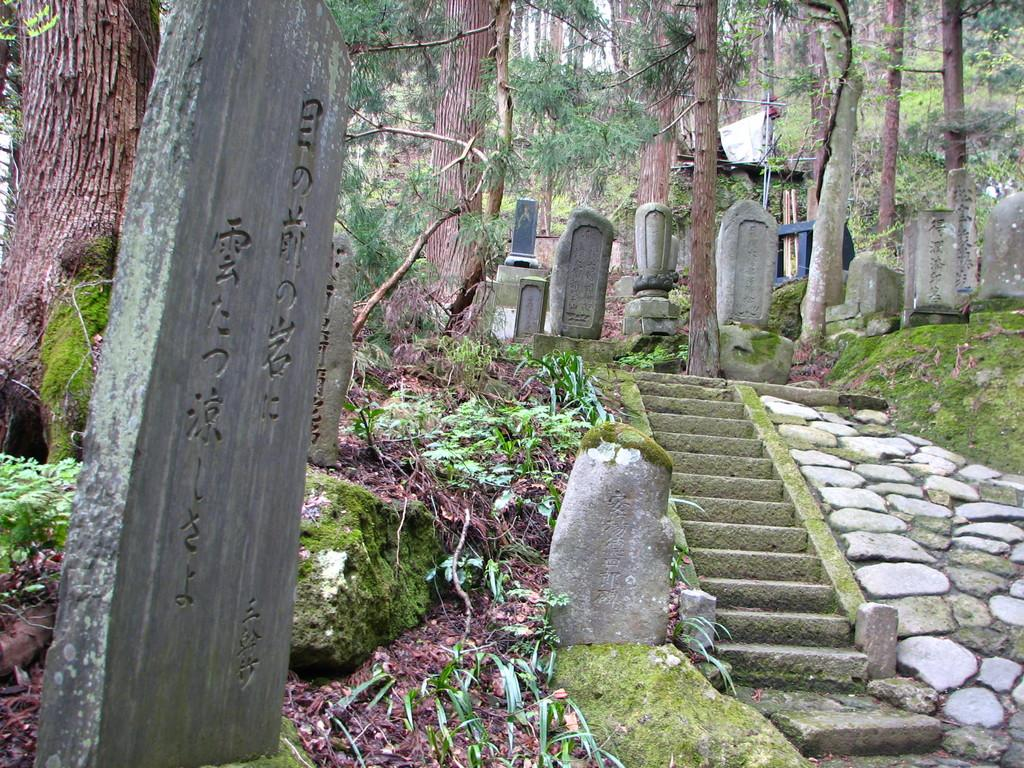What type of structure can be seen in the image? There is a concrete pole in the image. What architectural feature is present in the image? There are stairs in the image. What type of vegetation is visible in the image? There are trees and grass in the image. What natural elements can be seen in the image? There are rocks in the image. What is visible in the background of the image? There are trees and the sky in the background of the image. How many feathers can be seen on the ground in the image? There are no feathers present in the image. What type of event is taking place in the image? There is no event depicted in the image; it shows a concrete pole, stairs, trees, rocks, grass, and the sky. 